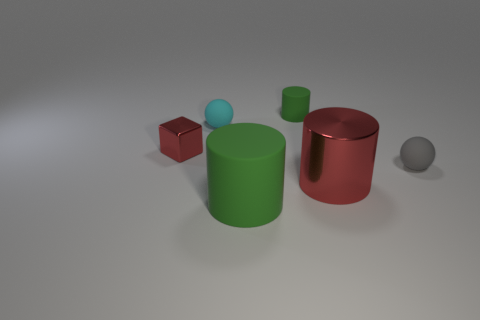Are there any cyan objects that have the same size as the red cylinder?
Your answer should be compact. No. What is the shape of the gray thing?
Provide a succinct answer. Sphere. What number of spheres are either big red objects or red objects?
Keep it short and to the point. 0. Are there the same number of objects that are right of the small green thing and green matte things that are behind the big shiny object?
Provide a short and direct response. No. There is a rubber cylinder that is in front of the green rubber cylinder behind the big metallic thing; how many red metal cubes are behind it?
Keep it short and to the point. 1. What is the shape of the large object that is the same color as the tiny shiny block?
Offer a terse response. Cylinder. There is a metal cylinder; is it the same color as the rubber thing that is in front of the small gray ball?
Offer a terse response. No. Are there more large things in front of the red metallic cylinder than rubber objects?
Provide a succinct answer. No. What number of objects are either spheres behind the red cube or red metallic things that are on the right side of the tiny red shiny object?
Your response must be concise. 2. What is the size of the red thing that is made of the same material as the large red cylinder?
Give a very brief answer. Small. 